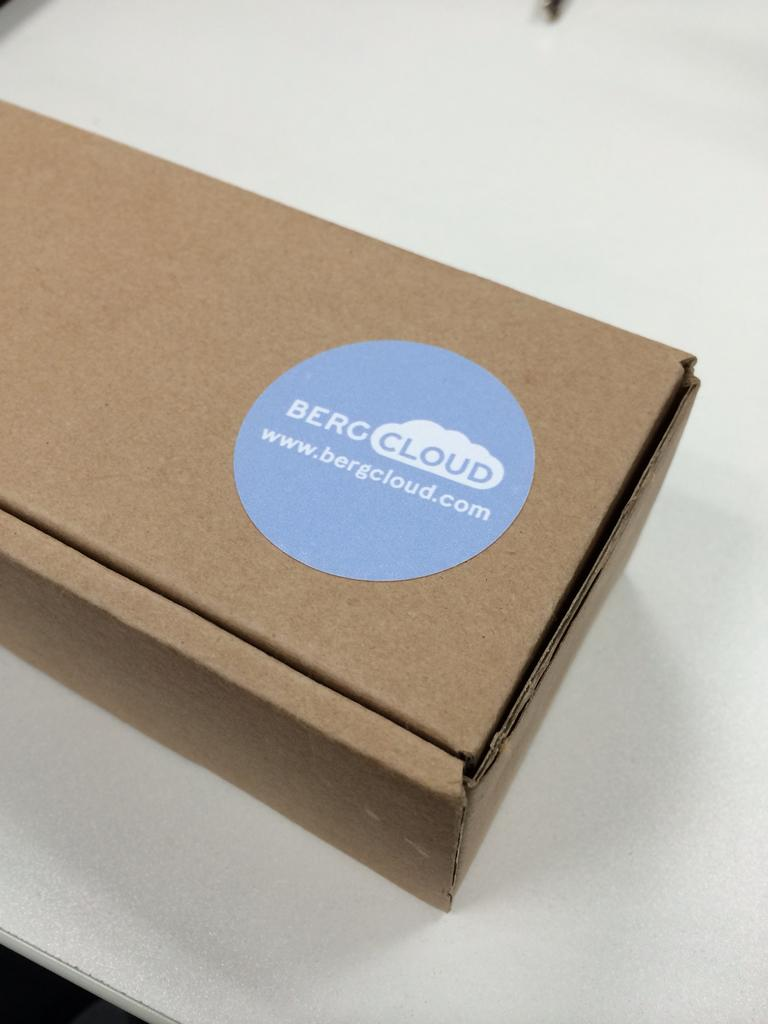<image>
Share a concise interpretation of the image provided. A cardboard box is labeled with the company name Bergcloud. 